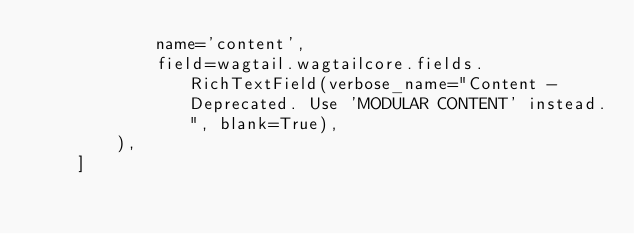Convert code to text. <code><loc_0><loc_0><loc_500><loc_500><_Python_>            name='content',
            field=wagtail.wagtailcore.fields.RichTextField(verbose_name="Content - Deprecated. Use 'MODULAR CONTENT' instead.", blank=True),
        ),
    ]
</code> 